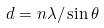Convert formula to latex. <formula><loc_0><loc_0><loc_500><loc_500>d = n \lambda / \sin \theta</formula> 